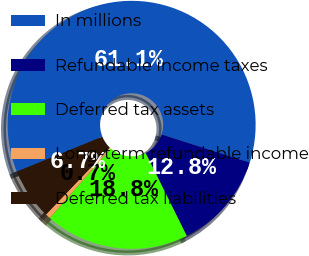Convert chart. <chart><loc_0><loc_0><loc_500><loc_500><pie_chart><fcel>In millions<fcel>Refundable income taxes<fcel>Deferred tax assets<fcel>Long-term refundable income<fcel>Deferred tax liabilities<nl><fcel>61.08%<fcel>12.75%<fcel>18.79%<fcel>0.67%<fcel>6.71%<nl></chart> 